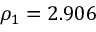<formula> <loc_0><loc_0><loc_500><loc_500>\rho _ { 1 } = 2 . 9 0 6</formula> 